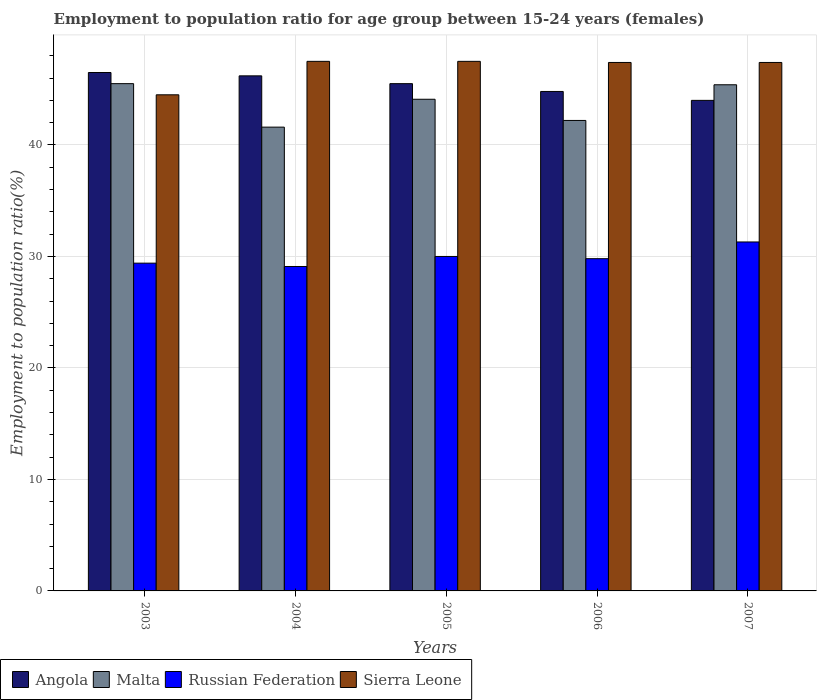Are the number of bars on each tick of the X-axis equal?
Give a very brief answer. Yes. How many bars are there on the 1st tick from the left?
Keep it short and to the point. 4. What is the employment to population ratio in Russian Federation in 2006?
Your response must be concise. 29.8. Across all years, what is the maximum employment to population ratio in Sierra Leone?
Give a very brief answer. 47.5. Across all years, what is the minimum employment to population ratio in Russian Federation?
Your answer should be compact. 29.1. In which year was the employment to population ratio in Sierra Leone maximum?
Offer a very short reply. 2004. In which year was the employment to population ratio in Russian Federation minimum?
Your answer should be very brief. 2004. What is the total employment to population ratio in Russian Federation in the graph?
Offer a terse response. 149.6. What is the difference between the employment to population ratio in Russian Federation in 2004 and that in 2007?
Make the answer very short. -2.2. What is the difference between the employment to population ratio in Malta in 2003 and the employment to population ratio in Russian Federation in 2006?
Ensure brevity in your answer.  15.7. What is the average employment to population ratio in Malta per year?
Give a very brief answer. 43.76. In the year 2005, what is the difference between the employment to population ratio in Sierra Leone and employment to population ratio in Angola?
Your answer should be compact. 2. What is the ratio of the employment to population ratio in Russian Federation in 2005 to that in 2006?
Provide a succinct answer. 1.01. What is the difference between the highest and the second highest employment to population ratio in Russian Federation?
Give a very brief answer. 1.3. Is the sum of the employment to population ratio in Angola in 2003 and 2007 greater than the maximum employment to population ratio in Malta across all years?
Your response must be concise. Yes. What does the 1st bar from the left in 2004 represents?
Offer a very short reply. Angola. What does the 4th bar from the right in 2007 represents?
Provide a short and direct response. Angola. Is it the case that in every year, the sum of the employment to population ratio in Russian Federation and employment to population ratio in Malta is greater than the employment to population ratio in Angola?
Your answer should be compact. Yes. Are all the bars in the graph horizontal?
Your answer should be very brief. No. How many years are there in the graph?
Keep it short and to the point. 5. Does the graph contain any zero values?
Give a very brief answer. No. How many legend labels are there?
Your answer should be compact. 4. What is the title of the graph?
Give a very brief answer. Employment to population ratio for age group between 15-24 years (females). Does "Morocco" appear as one of the legend labels in the graph?
Keep it short and to the point. No. What is the label or title of the X-axis?
Provide a short and direct response. Years. What is the label or title of the Y-axis?
Keep it short and to the point. Employment to population ratio(%). What is the Employment to population ratio(%) in Angola in 2003?
Provide a succinct answer. 46.5. What is the Employment to population ratio(%) of Malta in 2003?
Offer a very short reply. 45.5. What is the Employment to population ratio(%) in Russian Federation in 2003?
Ensure brevity in your answer.  29.4. What is the Employment to population ratio(%) in Sierra Leone in 2003?
Your answer should be compact. 44.5. What is the Employment to population ratio(%) of Angola in 2004?
Your response must be concise. 46.2. What is the Employment to population ratio(%) in Malta in 2004?
Ensure brevity in your answer.  41.6. What is the Employment to population ratio(%) of Russian Federation in 2004?
Your answer should be very brief. 29.1. What is the Employment to population ratio(%) in Sierra Leone in 2004?
Make the answer very short. 47.5. What is the Employment to population ratio(%) of Angola in 2005?
Provide a succinct answer. 45.5. What is the Employment to population ratio(%) in Malta in 2005?
Keep it short and to the point. 44.1. What is the Employment to population ratio(%) of Russian Federation in 2005?
Ensure brevity in your answer.  30. What is the Employment to population ratio(%) of Sierra Leone in 2005?
Provide a succinct answer. 47.5. What is the Employment to population ratio(%) in Angola in 2006?
Your answer should be compact. 44.8. What is the Employment to population ratio(%) of Malta in 2006?
Your answer should be compact. 42.2. What is the Employment to population ratio(%) of Russian Federation in 2006?
Make the answer very short. 29.8. What is the Employment to population ratio(%) in Sierra Leone in 2006?
Your answer should be very brief. 47.4. What is the Employment to population ratio(%) in Angola in 2007?
Offer a terse response. 44. What is the Employment to population ratio(%) of Malta in 2007?
Your answer should be compact. 45.4. What is the Employment to population ratio(%) in Russian Federation in 2007?
Provide a succinct answer. 31.3. What is the Employment to population ratio(%) of Sierra Leone in 2007?
Make the answer very short. 47.4. Across all years, what is the maximum Employment to population ratio(%) in Angola?
Make the answer very short. 46.5. Across all years, what is the maximum Employment to population ratio(%) of Malta?
Your response must be concise. 45.5. Across all years, what is the maximum Employment to population ratio(%) in Russian Federation?
Your response must be concise. 31.3. Across all years, what is the maximum Employment to population ratio(%) in Sierra Leone?
Provide a succinct answer. 47.5. Across all years, what is the minimum Employment to population ratio(%) in Malta?
Your answer should be compact. 41.6. Across all years, what is the minimum Employment to population ratio(%) of Russian Federation?
Make the answer very short. 29.1. Across all years, what is the minimum Employment to population ratio(%) in Sierra Leone?
Make the answer very short. 44.5. What is the total Employment to population ratio(%) of Angola in the graph?
Provide a short and direct response. 227. What is the total Employment to population ratio(%) in Malta in the graph?
Give a very brief answer. 218.8. What is the total Employment to population ratio(%) of Russian Federation in the graph?
Keep it short and to the point. 149.6. What is the total Employment to population ratio(%) in Sierra Leone in the graph?
Provide a succinct answer. 234.3. What is the difference between the Employment to population ratio(%) of Angola in 2003 and that in 2004?
Ensure brevity in your answer.  0.3. What is the difference between the Employment to population ratio(%) in Russian Federation in 2003 and that in 2004?
Ensure brevity in your answer.  0.3. What is the difference between the Employment to population ratio(%) of Angola in 2003 and that in 2006?
Ensure brevity in your answer.  1.7. What is the difference between the Employment to population ratio(%) of Russian Federation in 2003 and that in 2006?
Offer a very short reply. -0.4. What is the difference between the Employment to population ratio(%) of Malta in 2003 and that in 2007?
Provide a succinct answer. 0.1. What is the difference between the Employment to population ratio(%) of Sierra Leone in 2003 and that in 2007?
Make the answer very short. -2.9. What is the difference between the Employment to population ratio(%) of Angola in 2004 and that in 2005?
Make the answer very short. 0.7. What is the difference between the Employment to population ratio(%) of Russian Federation in 2004 and that in 2005?
Give a very brief answer. -0.9. What is the difference between the Employment to population ratio(%) in Sierra Leone in 2004 and that in 2005?
Ensure brevity in your answer.  0. What is the difference between the Employment to population ratio(%) in Malta in 2004 and that in 2006?
Ensure brevity in your answer.  -0.6. What is the difference between the Employment to population ratio(%) in Russian Federation in 2004 and that in 2006?
Offer a terse response. -0.7. What is the difference between the Employment to population ratio(%) in Angola in 2004 and that in 2007?
Provide a short and direct response. 2.2. What is the difference between the Employment to population ratio(%) in Russian Federation in 2004 and that in 2007?
Keep it short and to the point. -2.2. What is the difference between the Employment to population ratio(%) of Malta in 2005 and that in 2006?
Offer a very short reply. 1.9. What is the difference between the Employment to population ratio(%) of Russian Federation in 2005 and that in 2006?
Provide a short and direct response. 0.2. What is the difference between the Employment to population ratio(%) of Malta in 2005 and that in 2007?
Your answer should be compact. -1.3. What is the difference between the Employment to population ratio(%) of Angola in 2006 and that in 2007?
Offer a terse response. 0.8. What is the difference between the Employment to population ratio(%) of Russian Federation in 2006 and that in 2007?
Offer a very short reply. -1.5. What is the difference between the Employment to population ratio(%) in Angola in 2003 and the Employment to population ratio(%) in Sierra Leone in 2004?
Keep it short and to the point. -1. What is the difference between the Employment to population ratio(%) of Malta in 2003 and the Employment to population ratio(%) of Sierra Leone in 2004?
Offer a terse response. -2. What is the difference between the Employment to population ratio(%) of Russian Federation in 2003 and the Employment to population ratio(%) of Sierra Leone in 2004?
Ensure brevity in your answer.  -18.1. What is the difference between the Employment to population ratio(%) of Russian Federation in 2003 and the Employment to population ratio(%) of Sierra Leone in 2005?
Make the answer very short. -18.1. What is the difference between the Employment to population ratio(%) in Angola in 2003 and the Employment to population ratio(%) in Sierra Leone in 2006?
Make the answer very short. -0.9. What is the difference between the Employment to population ratio(%) in Malta in 2003 and the Employment to population ratio(%) in Russian Federation in 2006?
Offer a very short reply. 15.7. What is the difference between the Employment to population ratio(%) of Malta in 2003 and the Employment to population ratio(%) of Sierra Leone in 2006?
Your answer should be very brief. -1.9. What is the difference between the Employment to population ratio(%) in Russian Federation in 2003 and the Employment to population ratio(%) in Sierra Leone in 2006?
Provide a short and direct response. -18. What is the difference between the Employment to population ratio(%) in Angola in 2003 and the Employment to population ratio(%) in Russian Federation in 2007?
Keep it short and to the point. 15.2. What is the difference between the Employment to population ratio(%) of Malta in 2003 and the Employment to population ratio(%) of Sierra Leone in 2007?
Offer a very short reply. -1.9. What is the difference between the Employment to population ratio(%) of Russian Federation in 2003 and the Employment to population ratio(%) of Sierra Leone in 2007?
Your response must be concise. -18. What is the difference between the Employment to population ratio(%) of Angola in 2004 and the Employment to population ratio(%) of Malta in 2005?
Keep it short and to the point. 2.1. What is the difference between the Employment to population ratio(%) of Angola in 2004 and the Employment to population ratio(%) of Sierra Leone in 2005?
Make the answer very short. -1.3. What is the difference between the Employment to population ratio(%) in Malta in 2004 and the Employment to population ratio(%) in Russian Federation in 2005?
Give a very brief answer. 11.6. What is the difference between the Employment to population ratio(%) in Malta in 2004 and the Employment to population ratio(%) in Sierra Leone in 2005?
Offer a very short reply. -5.9. What is the difference between the Employment to population ratio(%) in Russian Federation in 2004 and the Employment to population ratio(%) in Sierra Leone in 2005?
Make the answer very short. -18.4. What is the difference between the Employment to population ratio(%) of Angola in 2004 and the Employment to population ratio(%) of Malta in 2006?
Make the answer very short. 4. What is the difference between the Employment to population ratio(%) in Malta in 2004 and the Employment to population ratio(%) in Sierra Leone in 2006?
Provide a short and direct response. -5.8. What is the difference between the Employment to population ratio(%) of Russian Federation in 2004 and the Employment to population ratio(%) of Sierra Leone in 2006?
Provide a succinct answer. -18.3. What is the difference between the Employment to population ratio(%) in Angola in 2004 and the Employment to population ratio(%) in Malta in 2007?
Offer a very short reply. 0.8. What is the difference between the Employment to population ratio(%) of Angola in 2004 and the Employment to population ratio(%) of Russian Federation in 2007?
Your answer should be very brief. 14.9. What is the difference between the Employment to population ratio(%) in Malta in 2004 and the Employment to population ratio(%) in Sierra Leone in 2007?
Give a very brief answer. -5.8. What is the difference between the Employment to population ratio(%) in Russian Federation in 2004 and the Employment to population ratio(%) in Sierra Leone in 2007?
Your response must be concise. -18.3. What is the difference between the Employment to population ratio(%) of Angola in 2005 and the Employment to population ratio(%) of Malta in 2006?
Make the answer very short. 3.3. What is the difference between the Employment to population ratio(%) in Angola in 2005 and the Employment to population ratio(%) in Russian Federation in 2006?
Provide a short and direct response. 15.7. What is the difference between the Employment to population ratio(%) in Malta in 2005 and the Employment to population ratio(%) in Russian Federation in 2006?
Offer a very short reply. 14.3. What is the difference between the Employment to population ratio(%) of Malta in 2005 and the Employment to population ratio(%) of Sierra Leone in 2006?
Your answer should be compact. -3.3. What is the difference between the Employment to population ratio(%) in Russian Federation in 2005 and the Employment to population ratio(%) in Sierra Leone in 2006?
Provide a short and direct response. -17.4. What is the difference between the Employment to population ratio(%) of Angola in 2005 and the Employment to population ratio(%) of Russian Federation in 2007?
Ensure brevity in your answer.  14.2. What is the difference between the Employment to population ratio(%) in Malta in 2005 and the Employment to population ratio(%) in Sierra Leone in 2007?
Offer a terse response. -3.3. What is the difference between the Employment to population ratio(%) in Russian Federation in 2005 and the Employment to population ratio(%) in Sierra Leone in 2007?
Your answer should be compact. -17.4. What is the difference between the Employment to population ratio(%) of Angola in 2006 and the Employment to population ratio(%) of Russian Federation in 2007?
Offer a very short reply. 13.5. What is the difference between the Employment to population ratio(%) of Angola in 2006 and the Employment to population ratio(%) of Sierra Leone in 2007?
Give a very brief answer. -2.6. What is the difference between the Employment to population ratio(%) in Malta in 2006 and the Employment to population ratio(%) in Sierra Leone in 2007?
Your answer should be compact. -5.2. What is the difference between the Employment to population ratio(%) in Russian Federation in 2006 and the Employment to population ratio(%) in Sierra Leone in 2007?
Make the answer very short. -17.6. What is the average Employment to population ratio(%) in Angola per year?
Provide a short and direct response. 45.4. What is the average Employment to population ratio(%) of Malta per year?
Your answer should be very brief. 43.76. What is the average Employment to population ratio(%) of Russian Federation per year?
Provide a short and direct response. 29.92. What is the average Employment to population ratio(%) in Sierra Leone per year?
Provide a succinct answer. 46.86. In the year 2003, what is the difference between the Employment to population ratio(%) in Angola and Employment to population ratio(%) in Malta?
Make the answer very short. 1. In the year 2003, what is the difference between the Employment to population ratio(%) in Angola and Employment to population ratio(%) in Sierra Leone?
Provide a succinct answer. 2. In the year 2003, what is the difference between the Employment to population ratio(%) in Malta and Employment to population ratio(%) in Russian Federation?
Provide a short and direct response. 16.1. In the year 2003, what is the difference between the Employment to population ratio(%) in Russian Federation and Employment to population ratio(%) in Sierra Leone?
Provide a short and direct response. -15.1. In the year 2004, what is the difference between the Employment to population ratio(%) of Angola and Employment to population ratio(%) of Russian Federation?
Give a very brief answer. 17.1. In the year 2004, what is the difference between the Employment to population ratio(%) of Russian Federation and Employment to population ratio(%) of Sierra Leone?
Provide a succinct answer. -18.4. In the year 2005, what is the difference between the Employment to population ratio(%) in Angola and Employment to population ratio(%) in Russian Federation?
Your answer should be compact. 15.5. In the year 2005, what is the difference between the Employment to population ratio(%) in Malta and Employment to population ratio(%) in Russian Federation?
Make the answer very short. 14.1. In the year 2005, what is the difference between the Employment to population ratio(%) in Malta and Employment to population ratio(%) in Sierra Leone?
Keep it short and to the point. -3.4. In the year 2005, what is the difference between the Employment to population ratio(%) of Russian Federation and Employment to population ratio(%) of Sierra Leone?
Offer a terse response. -17.5. In the year 2006, what is the difference between the Employment to population ratio(%) in Angola and Employment to population ratio(%) in Russian Federation?
Give a very brief answer. 15. In the year 2006, what is the difference between the Employment to population ratio(%) in Angola and Employment to population ratio(%) in Sierra Leone?
Offer a terse response. -2.6. In the year 2006, what is the difference between the Employment to population ratio(%) in Russian Federation and Employment to population ratio(%) in Sierra Leone?
Ensure brevity in your answer.  -17.6. In the year 2007, what is the difference between the Employment to population ratio(%) in Angola and Employment to population ratio(%) in Russian Federation?
Your answer should be compact. 12.7. In the year 2007, what is the difference between the Employment to population ratio(%) in Angola and Employment to population ratio(%) in Sierra Leone?
Keep it short and to the point. -3.4. In the year 2007, what is the difference between the Employment to population ratio(%) of Russian Federation and Employment to population ratio(%) of Sierra Leone?
Give a very brief answer. -16.1. What is the ratio of the Employment to population ratio(%) in Malta in 2003 to that in 2004?
Keep it short and to the point. 1.09. What is the ratio of the Employment to population ratio(%) of Russian Federation in 2003 to that in 2004?
Offer a very short reply. 1.01. What is the ratio of the Employment to population ratio(%) of Sierra Leone in 2003 to that in 2004?
Give a very brief answer. 0.94. What is the ratio of the Employment to population ratio(%) of Angola in 2003 to that in 2005?
Offer a terse response. 1.02. What is the ratio of the Employment to population ratio(%) of Malta in 2003 to that in 2005?
Your answer should be very brief. 1.03. What is the ratio of the Employment to population ratio(%) in Russian Federation in 2003 to that in 2005?
Your answer should be very brief. 0.98. What is the ratio of the Employment to population ratio(%) of Sierra Leone in 2003 to that in 2005?
Your answer should be compact. 0.94. What is the ratio of the Employment to population ratio(%) of Angola in 2003 to that in 2006?
Offer a very short reply. 1.04. What is the ratio of the Employment to population ratio(%) of Malta in 2003 to that in 2006?
Give a very brief answer. 1.08. What is the ratio of the Employment to population ratio(%) in Russian Federation in 2003 to that in 2006?
Give a very brief answer. 0.99. What is the ratio of the Employment to population ratio(%) of Sierra Leone in 2003 to that in 2006?
Ensure brevity in your answer.  0.94. What is the ratio of the Employment to population ratio(%) in Angola in 2003 to that in 2007?
Your response must be concise. 1.06. What is the ratio of the Employment to population ratio(%) of Malta in 2003 to that in 2007?
Your answer should be very brief. 1. What is the ratio of the Employment to population ratio(%) in Russian Federation in 2003 to that in 2007?
Offer a terse response. 0.94. What is the ratio of the Employment to population ratio(%) of Sierra Leone in 2003 to that in 2007?
Offer a very short reply. 0.94. What is the ratio of the Employment to population ratio(%) in Angola in 2004 to that in 2005?
Provide a short and direct response. 1.02. What is the ratio of the Employment to population ratio(%) in Malta in 2004 to that in 2005?
Provide a short and direct response. 0.94. What is the ratio of the Employment to population ratio(%) in Sierra Leone in 2004 to that in 2005?
Give a very brief answer. 1. What is the ratio of the Employment to population ratio(%) of Angola in 2004 to that in 2006?
Keep it short and to the point. 1.03. What is the ratio of the Employment to population ratio(%) in Malta in 2004 to that in 2006?
Offer a terse response. 0.99. What is the ratio of the Employment to population ratio(%) in Russian Federation in 2004 to that in 2006?
Offer a terse response. 0.98. What is the ratio of the Employment to population ratio(%) in Sierra Leone in 2004 to that in 2006?
Give a very brief answer. 1. What is the ratio of the Employment to population ratio(%) in Angola in 2004 to that in 2007?
Your answer should be very brief. 1.05. What is the ratio of the Employment to population ratio(%) in Malta in 2004 to that in 2007?
Keep it short and to the point. 0.92. What is the ratio of the Employment to population ratio(%) of Russian Federation in 2004 to that in 2007?
Offer a very short reply. 0.93. What is the ratio of the Employment to population ratio(%) in Sierra Leone in 2004 to that in 2007?
Give a very brief answer. 1. What is the ratio of the Employment to population ratio(%) in Angola in 2005 to that in 2006?
Your answer should be very brief. 1.02. What is the ratio of the Employment to population ratio(%) of Malta in 2005 to that in 2006?
Offer a very short reply. 1.04. What is the ratio of the Employment to population ratio(%) of Russian Federation in 2005 to that in 2006?
Offer a very short reply. 1.01. What is the ratio of the Employment to population ratio(%) of Sierra Leone in 2005 to that in 2006?
Offer a terse response. 1. What is the ratio of the Employment to population ratio(%) of Angola in 2005 to that in 2007?
Provide a succinct answer. 1.03. What is the ratio of the Employment to population ratio(%) in Malta in 2005 to that in 2007?
Keep it short and to the point. 0.97. What is the ratio of the Employment to population ratio(%) in Russian Federation in 2005 to that in 2007?
Your answer should be very brief. 0.96. What is the ratio of the Employment to population ratio(%) of Sierra Leone in 2005 to that in 2007?
Ensure brevity in your answer.  1. What is the ratio of the Employment to population ratio(%) of Angola in 2006 to that in 2007?
Your response must be concise. 1.02. What is the ratio of the Employment to population ratio(%) of Malta in 2006 to that in 2007?
Give a very brief answer. 0.93. What is the ratio of the Employment to population ratio(%) in Russian Federation in 2006 to that in 2007?
Make the answer very short. 0.95. What is the difference between the highest and the second highest Employment to population ratio(%) in Angola?
Provide a short and direct response. 0.3. What is the difference between the highest and the second highest Employment to population ratio(%) in Sierra Leone?
Make the answer very short. 0. What is the difference between the highest and the lowest Employment to population ratio(%) in Malta?
Ensure brevity in your answer.  3.9. 